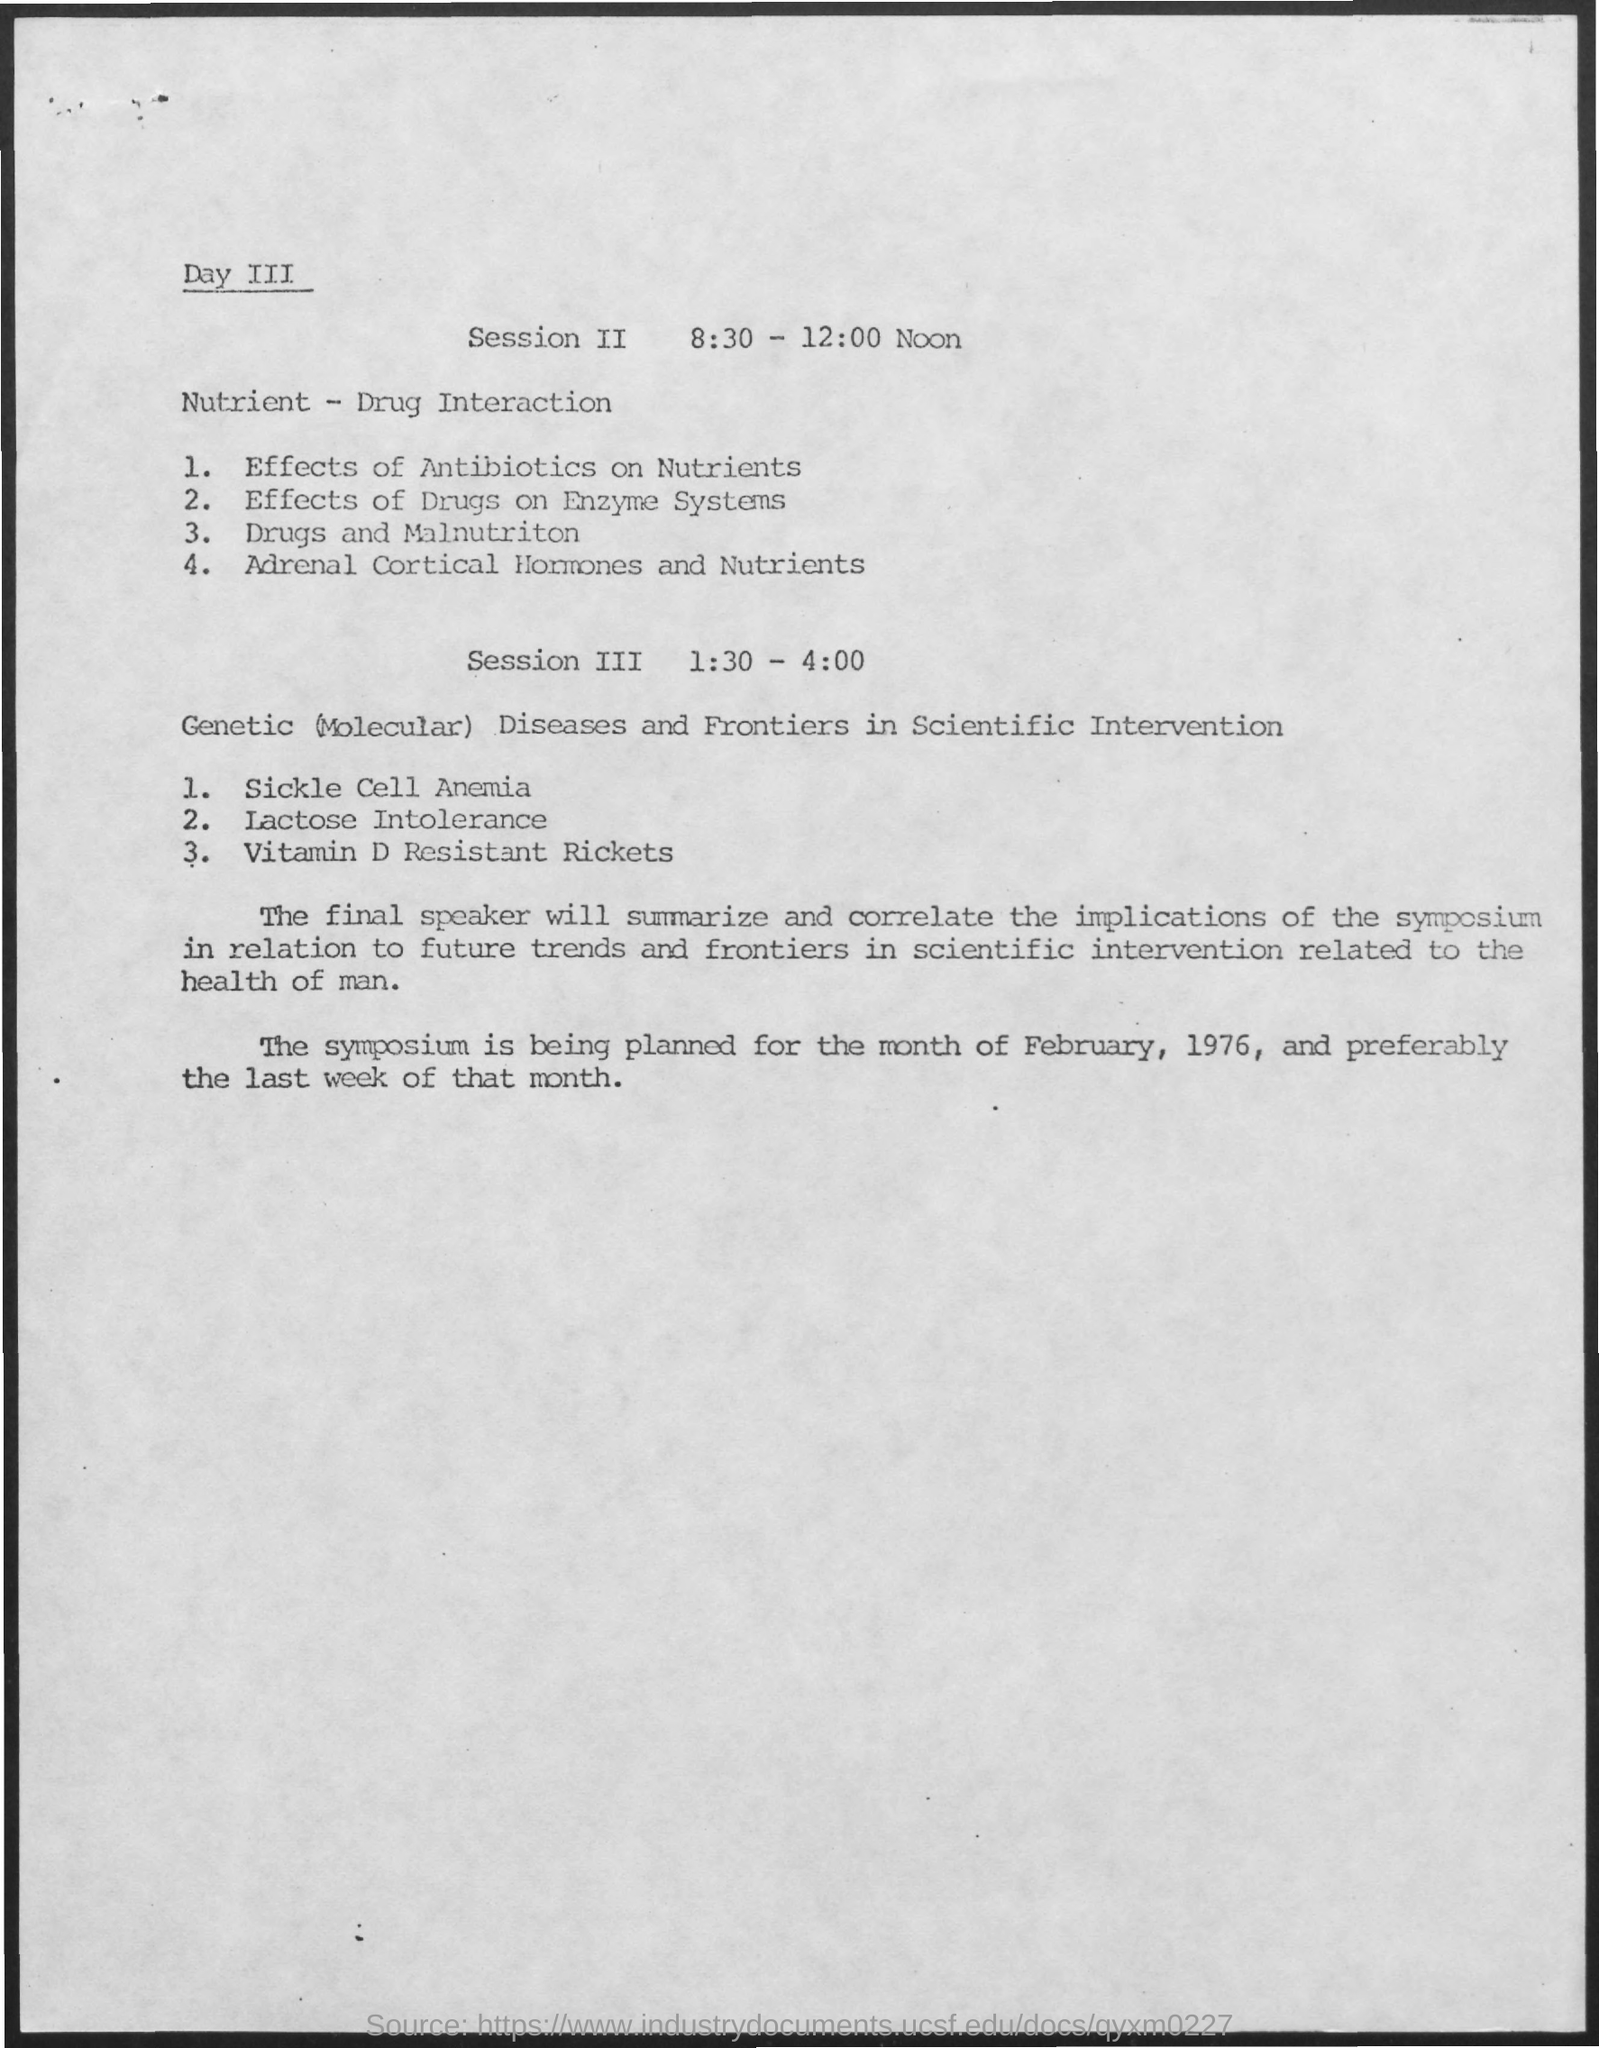What is the subject of session two on day 3?
Offer a very short reply. Nutrient - Drug Interaction. 